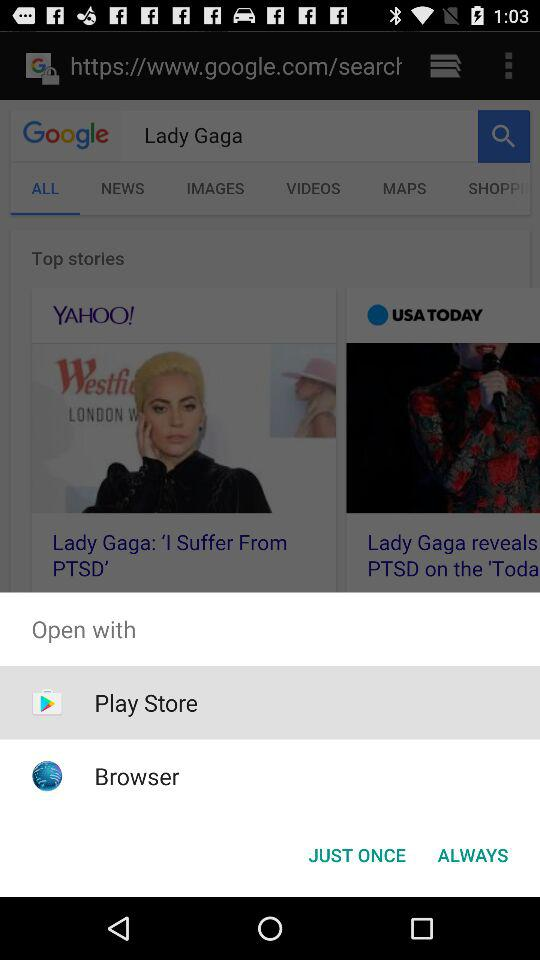Through which app can I open the content? You can open the content through "Play Store" and "Browser". 